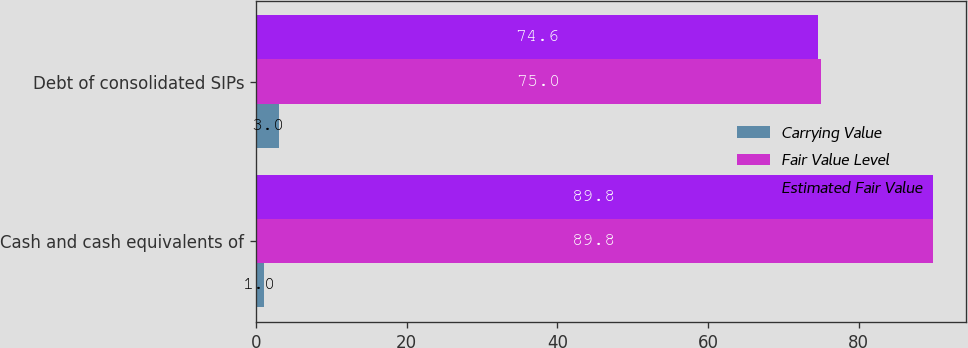<chart> <loc_0><loc_0><loc_500><loc_500><stacked_bar_chart><ecel><fcel>Cash and cash equivalents of<fcel>Debt of consolidated SIPs<nl><fcel>Carrying Value<fcel>1<fcel>3<nl><fcel>Fair Value Level<fcel>89.8<fcel>75<nl><fcel>Estimated Fair Value<fcel>89.8<fcel>74.6<nl></chart> 